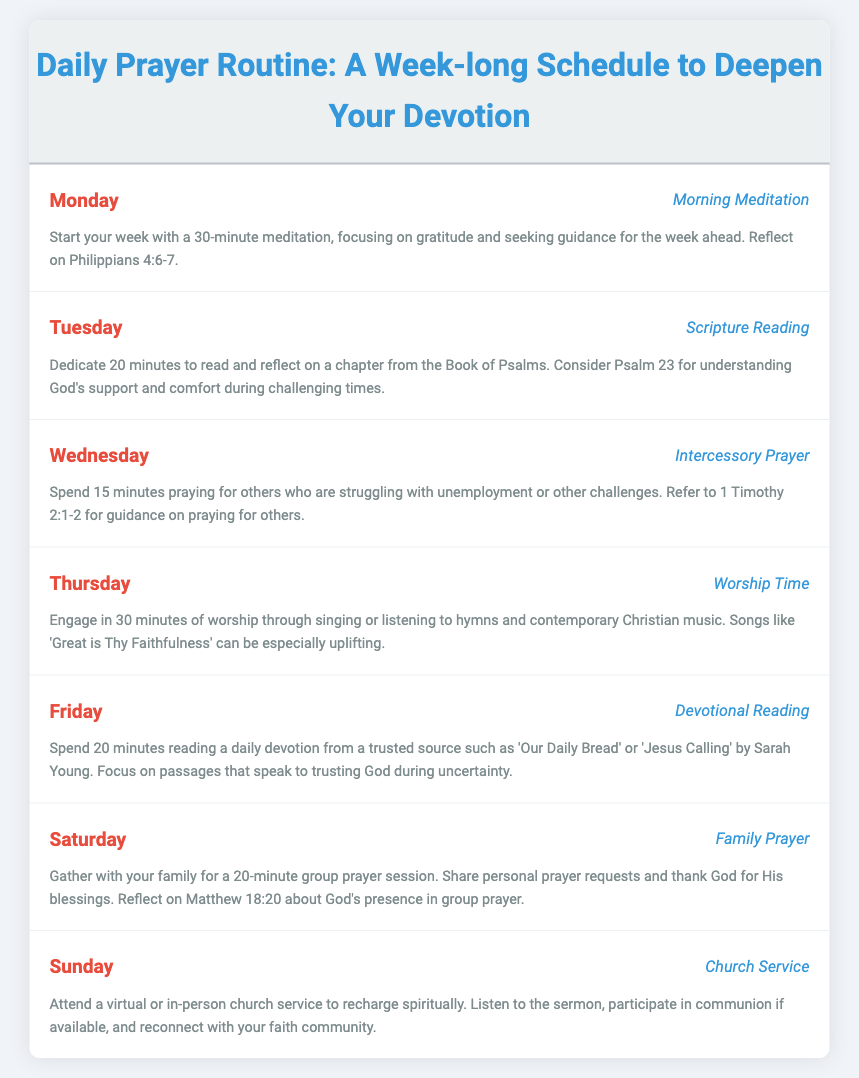What is the theme of the document? The theme is about establishing a daily prayer routine to deepen one's devotion throughout the week.
Answer: Daily Prayer Routine: A Week-long Schedule to Deepen Your Devotion How long should the Monday meditation last? The document specifies that the meditation on Monday should last for a certain duration.
Answer: 30 minutes Which book of the Bible is recommended for Tuesday's scripture reading? The Tuesday prayer routine suggests reading from a specific book in the Bible for reflection.
Answer: Book of Psalms What type of prayer is suggested for Wednesday? The document identifies a particular kind of prayer for Wednesdays that focuses on others.
Answer: Intercessory Prayer How many minutes should be devoted to family prayer on Saturday? The document indicates a specific time commitment for family prayer.
Answer: 20 minutes Which verse is referenced for understanding God's support on Tuesday? The document cites a Bible verse related to comfort and support during trying times.
Answer: Psalm 23 What activity is suggested for Thursday's prayer routine? The document outlines a specific activity for Thursday to engage spiritually.
Answer: Worship Time What example song is mentioned for Thursday's worship? A specific song is provided in the document as uplifting for the worship time.
Answer: Great is Thy Faithfulness How long is the suggested time for the devotional reading on Friday? The document specifies the duration set aside for this reading on Friday.
Answer: 20 minutes Which Gospel is referenced for group prayer on Saturday? The document mentions a particular Gospel that emphasizes God’s presence during group prayer.
Answer: Matthew 18:20 